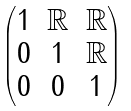Convert formula to latex. <formula><loc_0><loc_0><loc_500><loc_500>\begin{pmatrix} 1 & \mathbb { R } & \mathbb { R } \\ 0 & 1 & \mathbb { R } \\ 0 & 0 & 1 \end{pmatrix}</formula> 